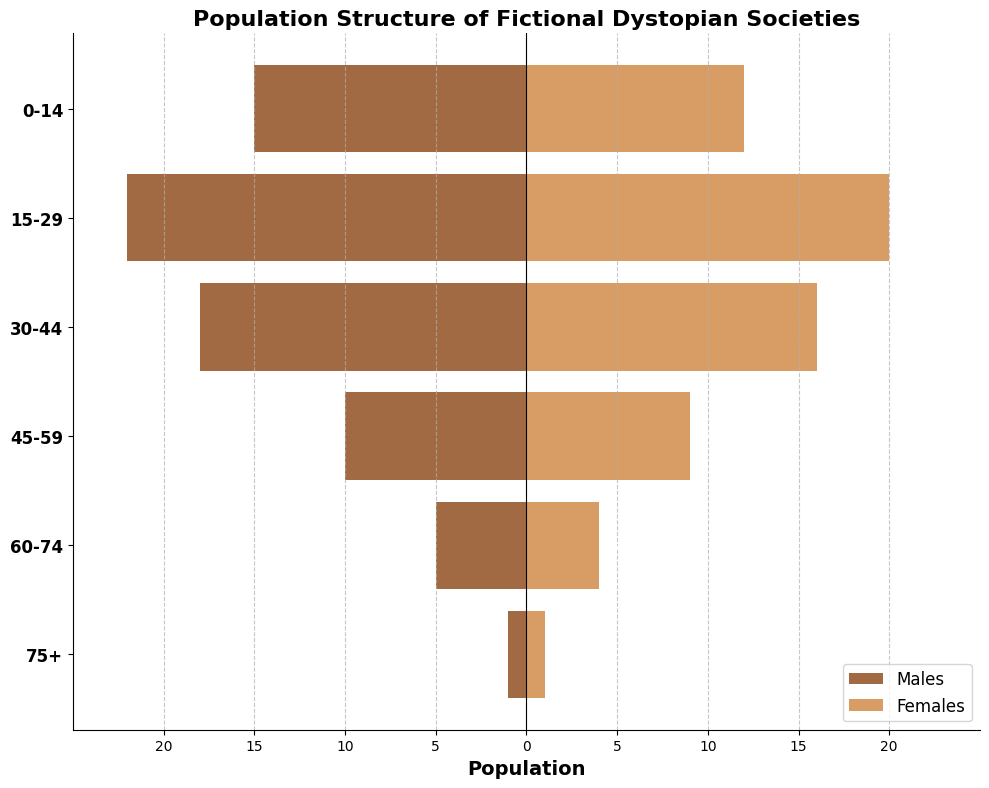What's the title of the figure? The title of a figure is typically displayed at the top and indicates the subject of the graph. In this case, it's "Population Structure of Fictional Dystopian Societies."
Answer: Population Structure of Fictional Dystopian Societies What are the axes representing? The x-axis represents the population (with positive numbers for females and negative numbers for males). The y-axis represents the age groups.
Answer: Population and Age Groups How many age groups are displayed? Count the number of unique age groups listed on the y-axis. They are 0-14, 15-29, 30-44, 45-59, 60-74, and 75+.
Answer: 6 Which age group has the highest number of males? Observe the horizontal bars extending to the left (males) and identify the longest bar. It's the group 15-29 with -22 males.
Answer: 15-29 How does the population of females aged 45-59 compare to the population of males in the same age group? Check the lengths of the bars for the age group 45-59. The female bar extends to 9, and the male bar extends to -10.
Answer: Slightly fewer females What's the total population (males and females) for the age group 30-44? Add the number of males and females in the age group 30-44. There are 18 males and 16 females, so 18 + 16 = 34.
Answer: 34 Which gender has a larger population in the age group 60-74? Compare the lengths of the bars for males and females in the 60-74 age group. The male bar extends to -5 and the female bar extends to 4.
Answer: Males What is the ratio of males to females in the youngest age group (0-14)? Calculate the ratio by dividing the number of males by females in the 0-14 age group. There are 15 males and 12 females, so the ratio is 15/12.
Answer: 1.25 Which age group has the smallest population? Find the age group with the shortest combined bar lengths. The 75+ group has 1 male and 1 female, totaling only 2.
Answer: 75+ How does the population distribution change as age increases? Describe the overall trend by observing the bar lengths from youngest to oldest. The population decreases for both genders as age increases.
Answer: Decreases with age 